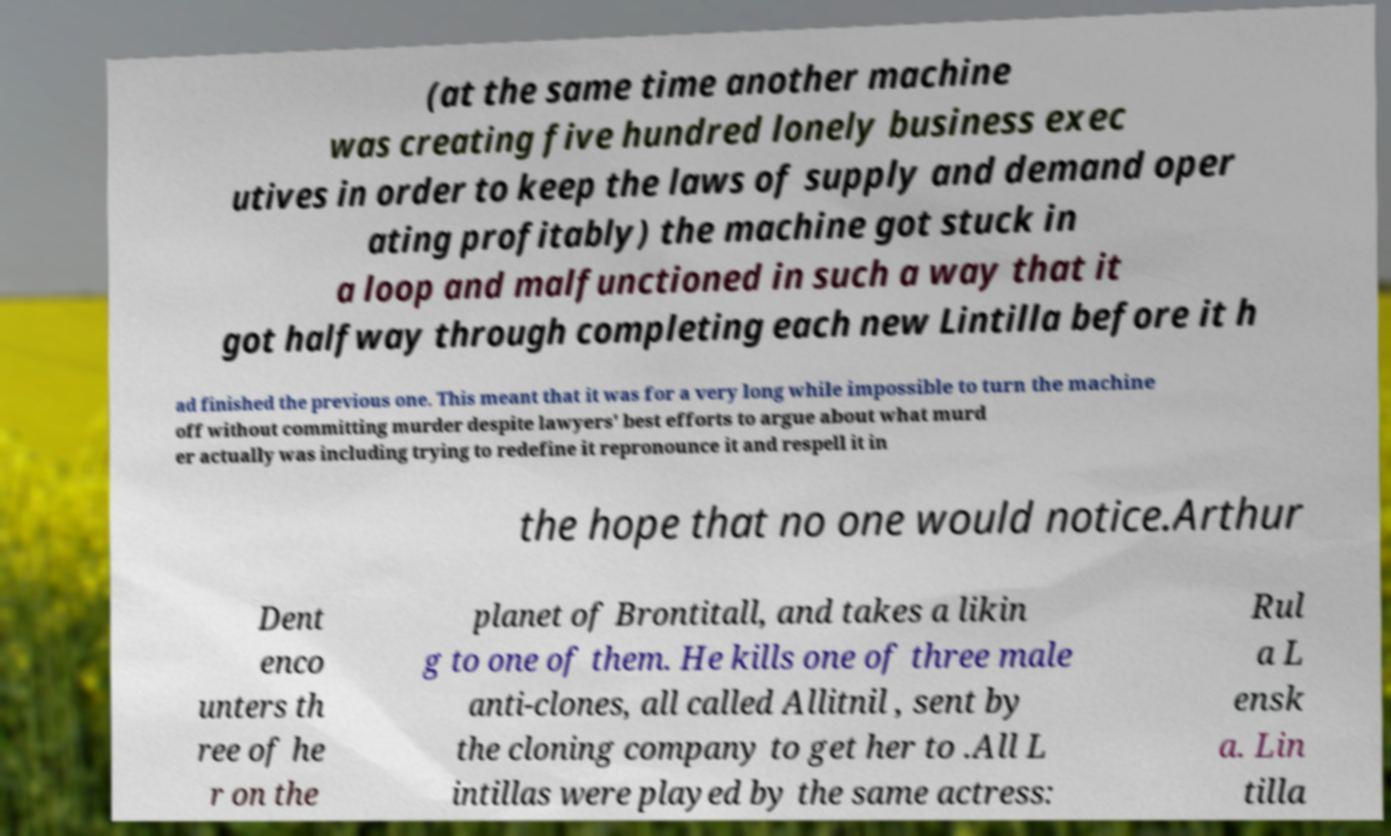Please identify and transcribe the text found in this image. (at the same time another machine was creating five hundred lonely business exec utives in order to keep the laws of supply and demand oper ating profitably) the machine got stuck in a loop and malfunctioned in such a way that it got halfway through completing each new Lintilla before it h ad finished the previous one. This meant that it was for a very long while impossible to turn the machine off without committing murder despite lawyers' best efforts to argue about what murd er actually was including trying to redefine it repronounce it and respell it in the hope that no one would notice.Arthur Dent enco unters th ree of he r on the planet of Brontitall, and takes a likin g to one of them. He kills one of three male anti-clones, all called Allitnil , sent by the cloning company to get her to .All L intillas were played by the same actress: Rul a L ensk a. Lin tilla 